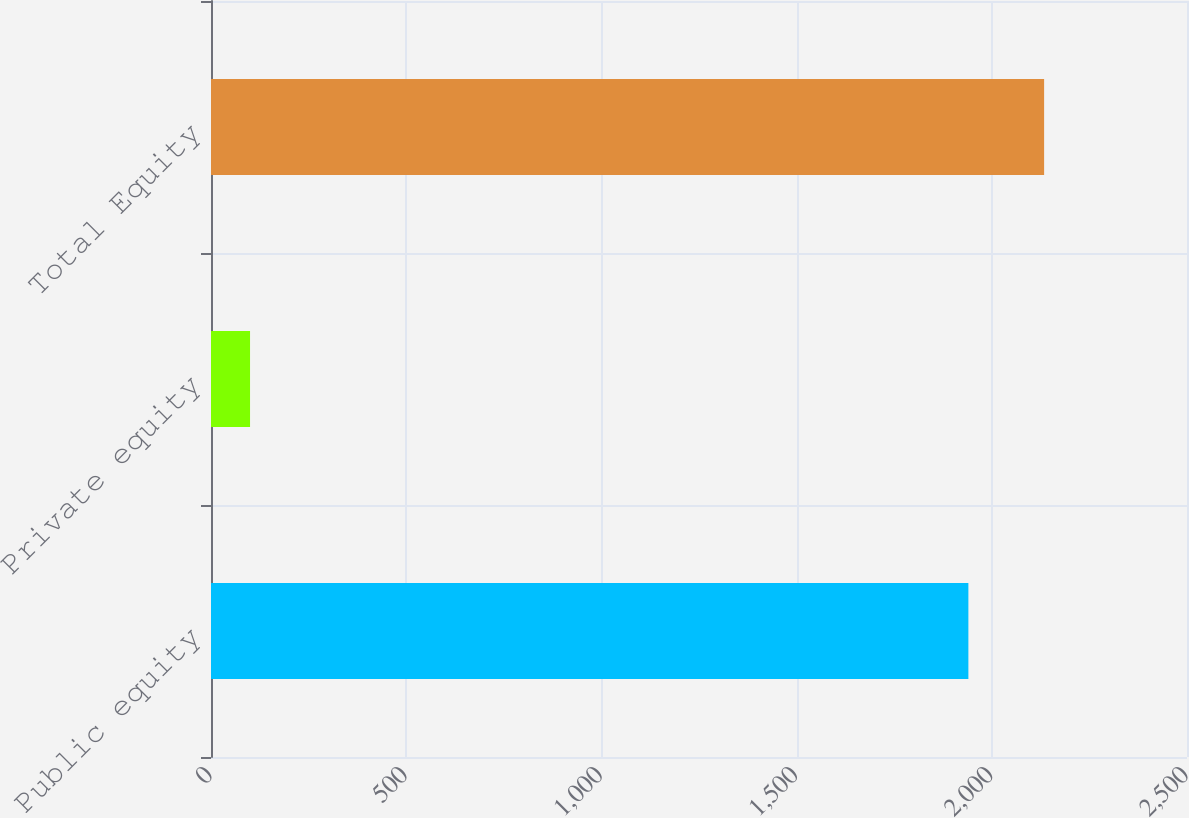Convert chart. <chart><loc_0><loc_0><loc_500><loc_500><bar_chart><fcel>Public equity<fcel>Private equity<fcel>Total Equity<nl><fcel>1940<fcel>100<fcel>2134<nl></chart> 